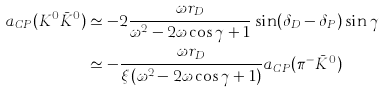<formula> <loc_0><loc_0><loc_500><loc_500>a _ { C P } ( K ^ { 0 } \bar { K } ^ { 0 } ) & \simeq - 2 \frac { \omega r _ { D } } { \omega ^ { 2 } - 2 \omega \cos \gamma + 1 } \sin ( \delta _ { D } - \delta _ { P } ) \sin \gamma \\ & \simeq - \frac { \omega r _ { D } } { \xi ( \omega ^ { 2 } - 2 \omega \cos \gamma + 1 ) } a _ { C P } ( \pi ^ { - } \bar { K } ^ { 0 } )</formula> 